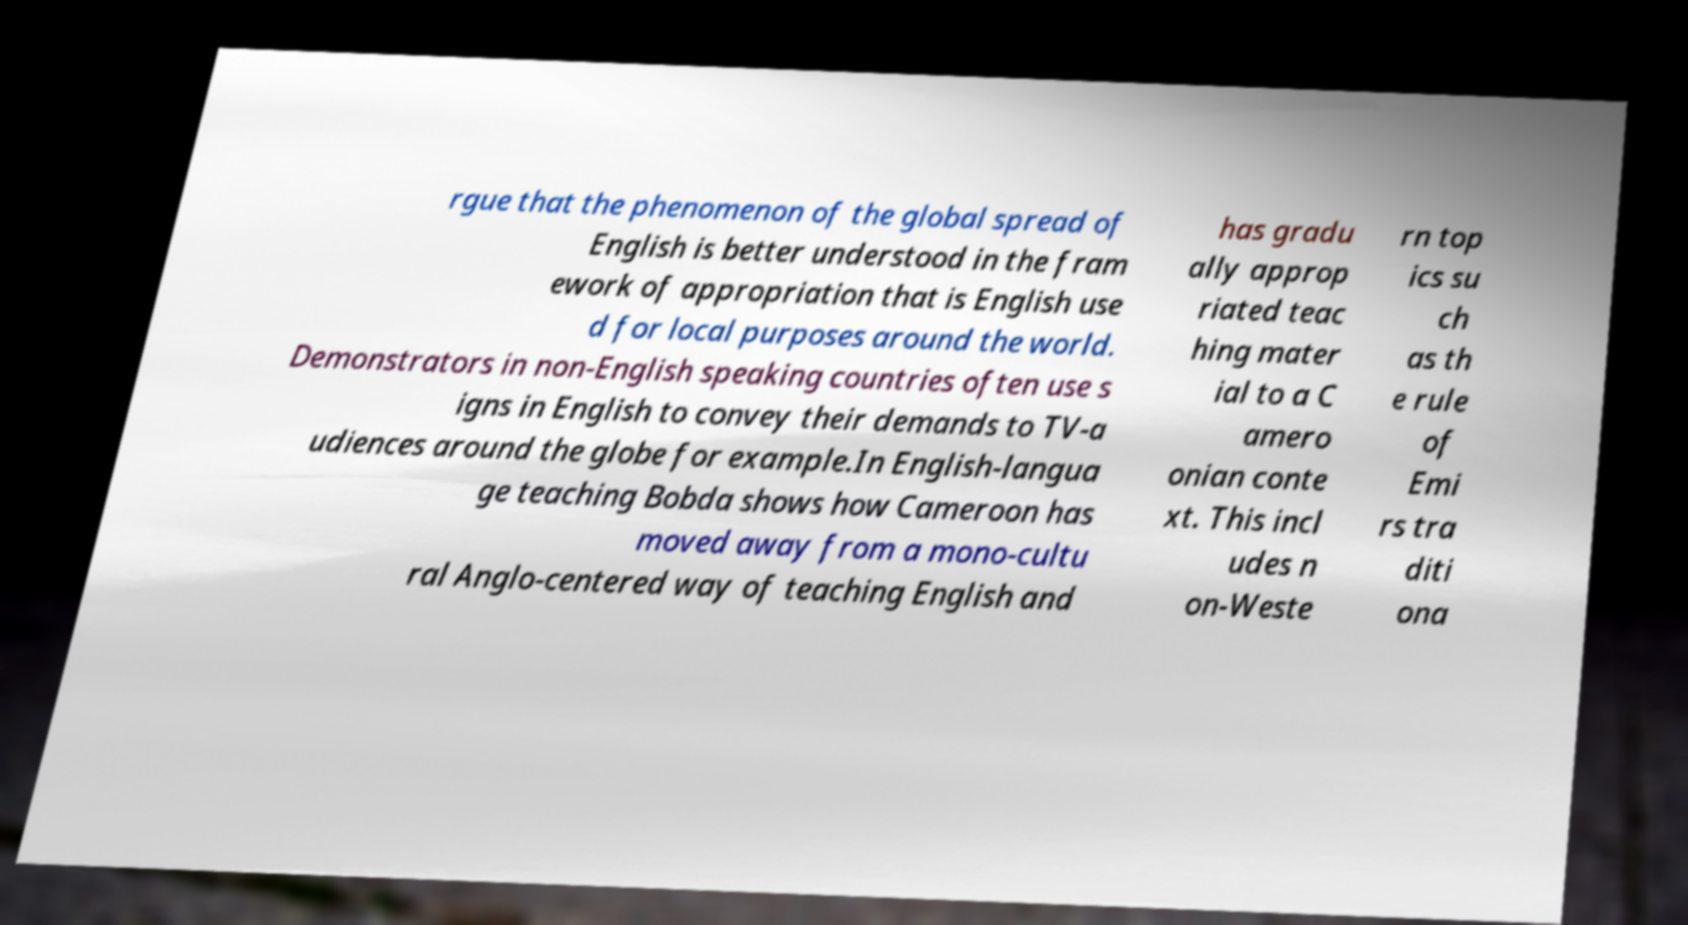Please identify and transcribe the text found in this image. rgue that the phenomenon of the global spread of English is better understood in the fram ework of appropriation that is English use d for local purposes around the world. Demonstrators in non-English speaking countries often use s igns in English to convey their demands to TV-a udiences around the globe for example.In English-langua ge teaching Bobda shows how Cameroon has moved away from a mono-cultu ral Anglo-centered way of teaching English and has gradu ally approp riated teac hing mater ial to a C amero onian conte xt. This incl udes n on-Weste rn top ics su ch as th e rule of Emi rs tra diti ona 